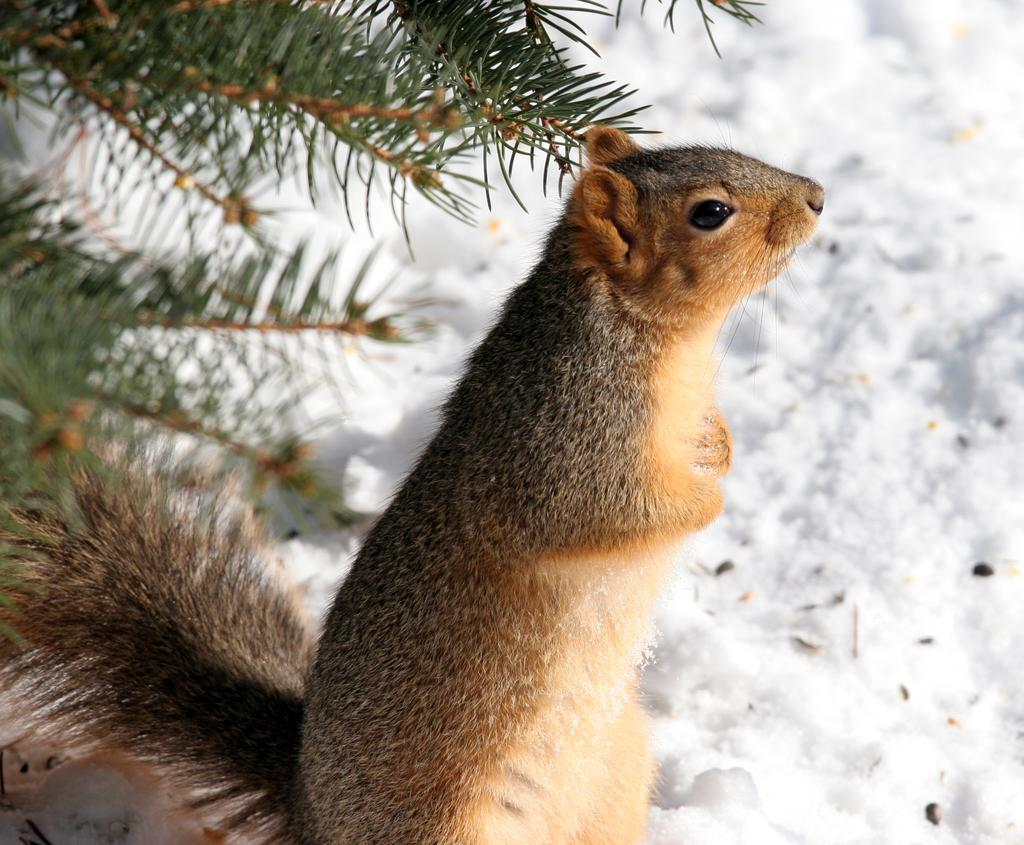What animal can be seen in the image? There is a squirrel in the image. In which direction is the squirrel facing? The squirrel is facing towards the right side. What can be seen in the background of the image? There is snow and a plant in the background of the image. What type of boats can be seen in the image? There are no boats present in the image; it features a squirrel in a snowy environment with a plant in the background. How does the squirrel's temper affect the plant in the image? The squirrel's temper is not mentioned in the image, and there is no indication that it has any effect on the plant. 